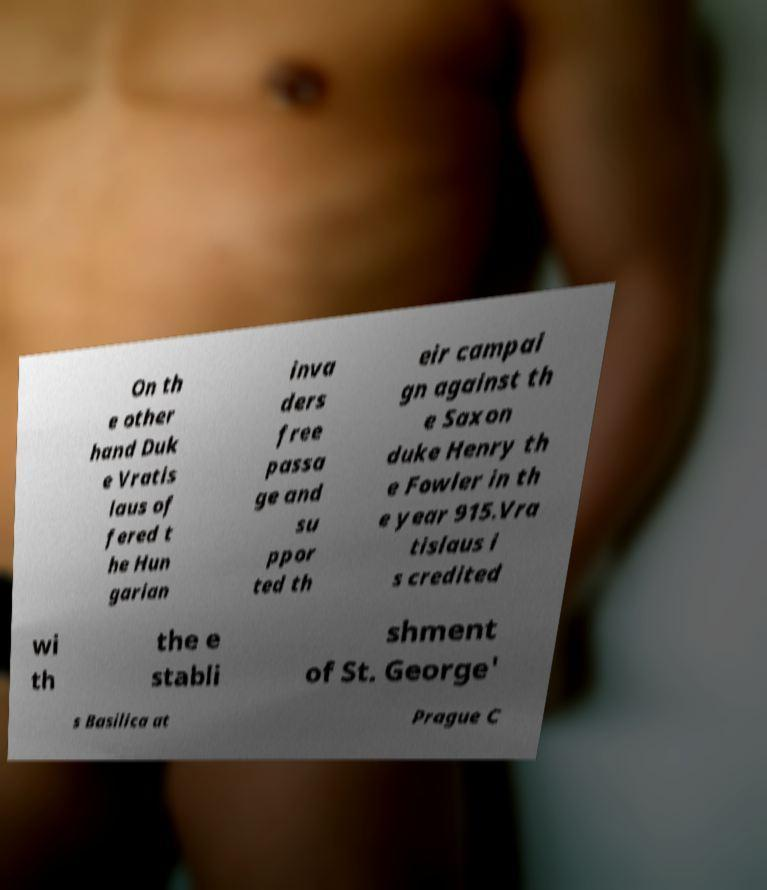Can you accurately transcribe the text from the provided image for me? On th e other hand Duk e Vratis laus of fered t he Hun garian inva ders free passa ge and su ppor ted th eir campai gn against th e Saxon duke Henry th e Fowler in th e year 915.Vra tislaus i s credited wi th the e stabli shment of St. George' s Basilica at Prague C 